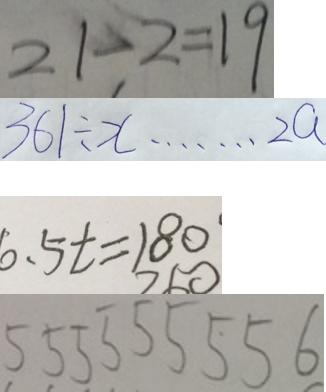Convert formula to latex. <formula><loc_0><loc_0><loc_500><loc_500>2 1 - 2 = 1 9 
 3 6 1 \div x \cdots 2 a 
 6 . 5 t = 1 8 0 ^ { \cdot } 
 5 5 5 5 5 5 5 5 6</formula> 